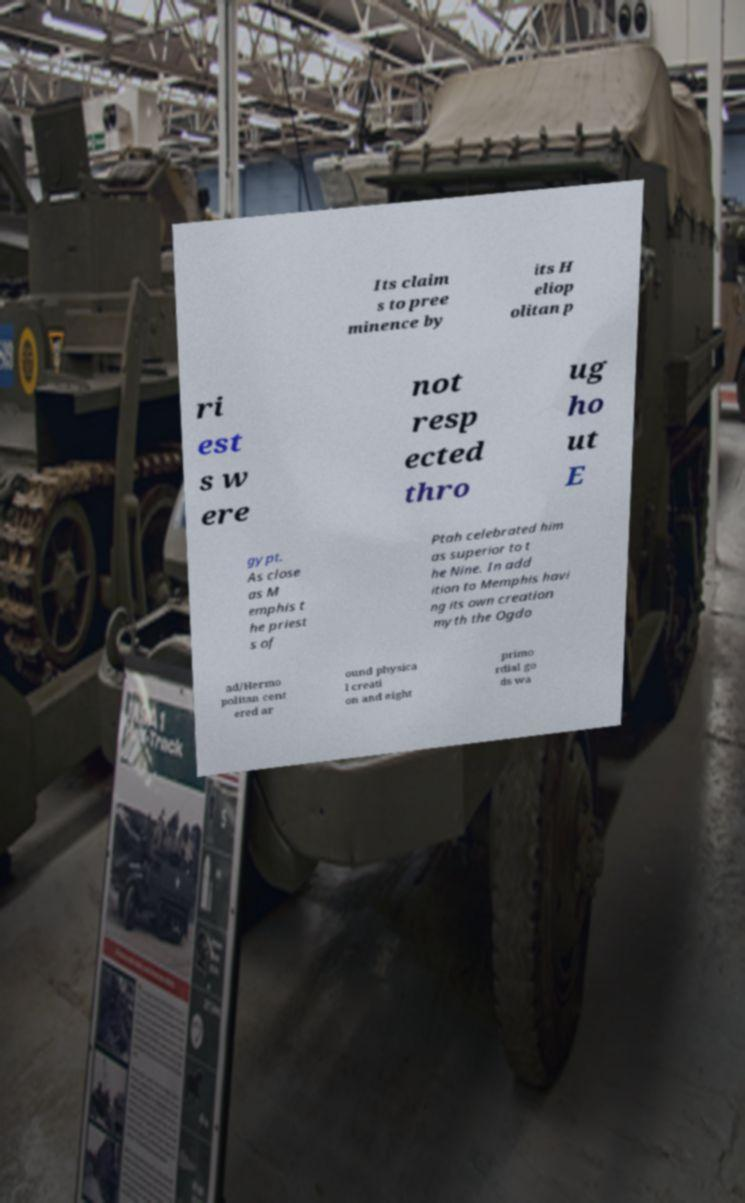Please read and relay the text visible in this image. What does it say? Its claim s to pree minence by its H eliop olitan p ri est s w ere not resp ected thro ug ho ut E gypt. As close as M emphis t he priest s of Ptah celebrated him as superior to t he Nine. In add ition to Memphis havi ng its own creation myth the Ogdo ad/Hermo politan cent ered ar ound physica l creati on and eight primo rdial go ds wa 